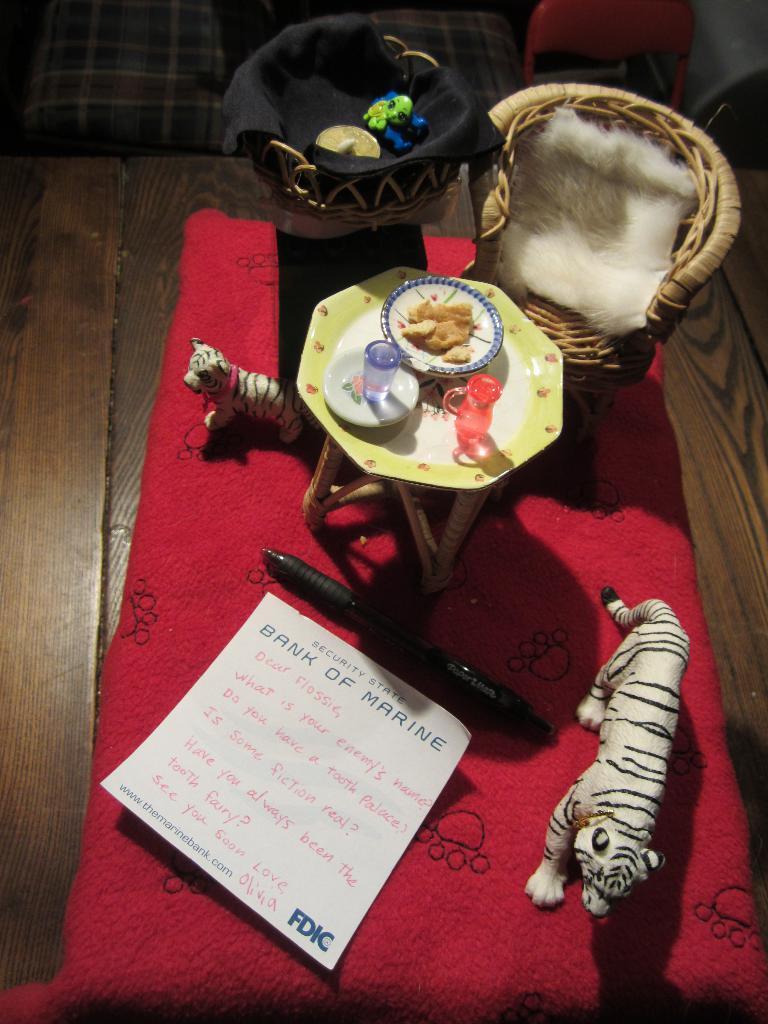Could you give a brief overview of what you see in this image? In this picture we can see greeting card, pen, toy of tigers, table, chairs placed on the table. 